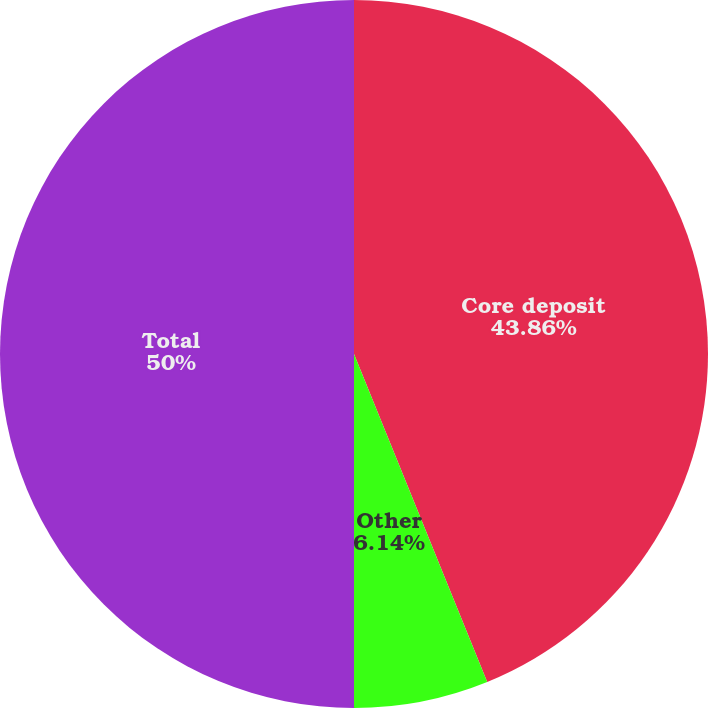<chart> <loc_0><loc_0><loc_500><loc_500><pie_chart><fcel>Core deposit<fcel>Other<fcel>Total<nl><fcel>43.86%<fcel>6.14%<fcel>50.0%<nl></chart> 